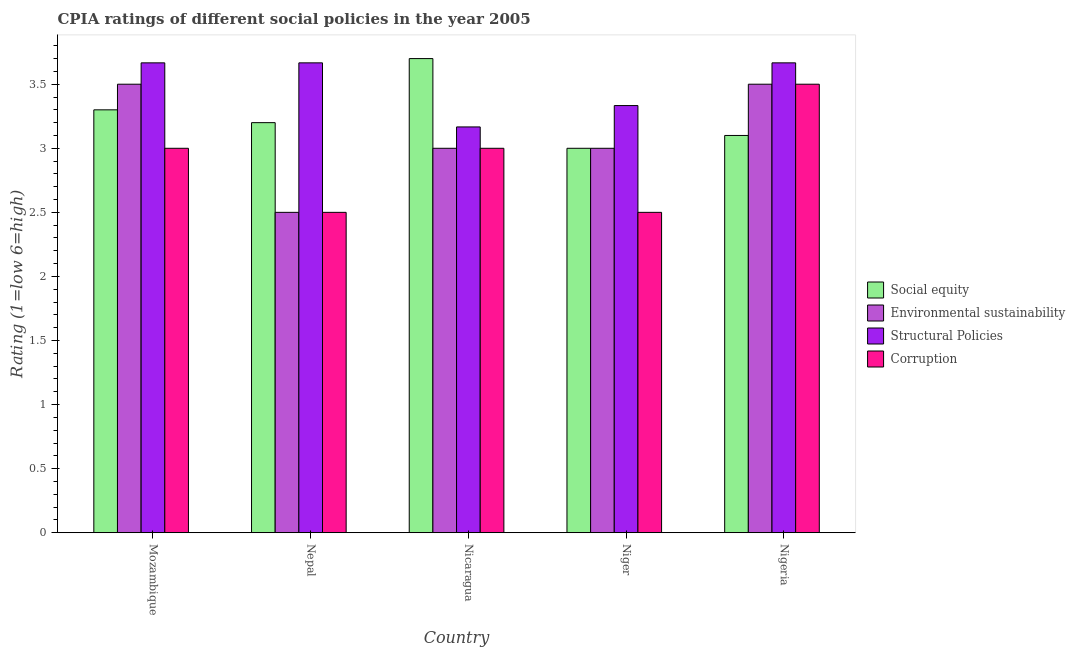How many different coloured bars are there?
Your answer should be very brief. 4. Are the number of bars per tick equal to the number of legend labels?
Your response must be concise. Yes. Are the number of bars on each tick of the X-axis equal?
Your answer should be compact. Yes. How many bars are there on the 3rd tick from the right?
Your answer should be very brief. 4. What is the label of the 5th group of bars from the left?
Ensure brevity in your answer.  Nigeria. What is the cpia rating of structural policies in Nigeria?
Provide a succinct answer. 3.67. Across all countries, what is the maximum cpia rating of social equity?
Keep it short and to the point. 3.7. In which country was the cpia rating of structural policies maximum?
Give a very brief answer. Mozambique. In which country was the cpia rating of environmental sustainability minimum?
Ensure brevity in your answer.  Nepal. What is the difference between the cpia rating of environmental sustainability in Nepal and the cpia rating of social equity in Nigeria?
Make the answer very short. -0.6. What is the difference between the cpia rating of social equity and cpia rating of structural policies in Nepal?
Ensure brevity in your answer.  -0.47. In how many countries, is the cpia rating of corruption greater than 2.5 ?
Give a very brief answer. 3. What is the ratio of the cpia rating of structural policies in Mozambique to that in Nicaragua?
Offer a very short reply. 1.16. Is the cpia rating of structural policies in Nicaragua less than that in Niger?
Give a very brief answer. Yes. Is the difference between the cpia rating of corruption in Nepal and Niger greater than the difference between the cpia rating of social equity in Nepal and Niger?
Offer a terse response. No. What is the difference between the highest and the second highest cpia rating of corruption?
Offer a terse response. 0.5. What does the 2nd bar from the left in Mozambique represents?
Your answer should be compact. Environmental sustainability. What does the 3rd bar from the right in Nicaragua represents?
Keep it short and to the point. Environmental sustainability. Is it the case that in every country, the sum of the cpia rating of social equity and cpia rating of environmental sustainability is greater than the cpia rating of structural policies?
Your response must be concise. Yes. Are all the bars in the graph horizontal?
Your answer should be very brief. No. How many countries are there in the graph?
Give a very brief answer. 5. What is the difference between two consecutive major ticks on the Y-axis?
Your response must be concise. 0.5. Does the graph contain any zero values?
Provide a short and direct response. No. Does the graph contain grids?
Your answer should be very brief. No. How many legend labels are there?
Offer a very short reply. 4. How are the legend labels stacked?
Offer a terse response. Vertical. What is the title of the graph?
Ensure brevity in your answer.  CPIA ratings of different social policies in the year 2005. Does "International Monetary Fund" appear as one of the legend labels in the graph?
Offer a very short reply. No. What is the label or title of the X-axis?
Your response must be concise. Country. What is the Rating (1=low 6=high) in Social equity in Mozambique?
Your answer should be compact. 3.3. What is the Rating (1=low 6=high) of Structural Policies in Mozambique?
Provide a short and direct response. 3.67. What is the Rating (1=low 6=high) of Corruption in Mozambique?
Provide a succinct answer. 3. What is the Rating (1=low 6=high) of Social equity in Nepal?
Offer a very short reply. 3.2. What is the Rating (1=low 6=high) of Structural Policies in Nepal?
Give a very brief answer. 3.67. What is the Rating (1=low 6=high) in Social equity in Nicaragua?
Provide a short and direct response. 3.7. What is the Rating (1=low 6=high) of Structural Policies in Nicaragua?
Offer a very short reply. 3.17. What is the Rating (1=low 6=high) of Environmental sustainability in Niger?
Provide a short and direct response. 3. What is the Rating (1=low 6=high) of Structural Policies in Niger?
Make the answer very short. 3.33. What is the Rating (1=low 6=high) in Corruption in Niger?
Your answer should be compact. 2.5. What is the Rating (1=low 6=high) of Social equity in Nigeria?
Ensure brevity in your answer.  3.1. What is the Rating (1=low 6=high) in Environmental sustainability in Nigeria?
Provide a short and direct response. 3.5. What is the Rating (1=low 6=high) of Structural Policies in Nigeria?
Give a very brief answer. 3.67. Across all countries, what is the maximum Rating (1=low 6=high) of Structural Policies?
Give a very brief answer. 3.67. Across all countries, what is the minimum Rating (1=low 6=high) in Social equity?
Ensure brevity in your answer.  3. Across all countries, what is the minimum Rating (1=low 6=high) in Environmental sustainability?
Give a very brief answer. 2.5. Across all countries, what is the minimum Rating (1=low 6=high) in Structural Policies?
Give a very brief answer. 3.17. Across all countries, what is the minimum Rating (1=low 6=high) of Corruption?
Provide a short and direct response. 2.5. What is the total Rating (1=low 6=high) in Structural Policies in the graph?
Make the answer very short. 17.5. What is the difference between the Rating (1=low 6=high) of Social equity in Mozambique and that in Nepal?
Your answer should be very brief. 0.1. What is the difference between the Rating (1=low 6=high) in Environmental sustainability in Mozambique and that in Nepal?
Offer a very short reply. 1. What is the difference between the Rating (1=low 6=high) of Structural Policies in Mozambique and that in Nepal?
Offer a terse response. 0. What is the difference between the Rating (1=low 6=high) in Environmental sustainability in Mozambique and that in Nicaragua?
Ensure brevity in your answer.  0.5. What is the difference between the Rating (1=low 6=high) in Structural Policies in Mozambique and that in Nicaragua?
Make the answer very short. 0.5. What is the difference between the Rating (1=low 6=high) in Social equity in Mozambique and that in Niger?
Your response must be concise. 0.3. What is the difference between the Rating (1=low 6=high) of Corruption in Mozambique and that in Niger?
Your response must be concise. 0.5. What is the difference between the Rating (1=low 6=high) of Environmental sustainability in Mozambique and that in Nigeria?
Keep it short and to the point. 0. What is the difference between the Rating (1=low 6=high) in Structural Policies in Mozambique and that in Nigeria?
Provide a succinct answer. 0. What is the difference between the Rating (1=low 6=high) of Environmental sustainability in Nepal and that in Nicaragua?
Provide a short and direct response. -0.5. What is the difference between the Rating (1=low 6=high) of Corruption in Nepal and that in Nicaragua?
Provide a short and direct response. -0.5. What is the difference between the Rating (1=low 6=high) in Social equity in Nepal and that in Niger?
Provide a succinct answer. 0.2. What is the difference between the Rating (1=low 6=high) of Corruption in Nepal and that in Niger?
Your answer should be very brief. 0. What is the difference between the Rating (1=low 6=high) in Social equity in Nepal and that in Nigeria?
Provide a short and direct response. 0.1. What is the difference between the Rating (1=low 6=high) of Corruption in Nepal and that in Nigeria?
Ensure brevity in your answer.  -1. What is the difference between the Rating (1=low 6=high) of Social equity in Nicaragua and that in Niger?
Give a very brief answer. 0.7. What is the difference between the Rating (1=low 6=high) of Structural Policies in Nicaragua and that in Niger?
Ensure brevity in your answer.  -0.17. What is the difference between the Rating (1=low 6=high) of Social equity in Nicaragua and that in Nigeria?
Keep it short and to the point. 0.6. What is the difference between the Rating (1=low 6=high) of Environmental sustainability in Nicaragua and that in Nigeria?
Your answer should be compact. -0.5. What is the difference between the Rating (1=low 6=high) of Structural Policies in Nicaragua and that in Nigeria?
Provide a short and direct response. -0.5. What is the difference between the Rating (1=low 6=high) in Corruption in Nicaragua and that in Nigeria?
Ensure brevity in your answer.  -0.5. What is the difference between the Rating (1=low 6=high) in Structural Policies in Niger and that in Nigeria?
Provide a short and direct response. -0.33. What is the difference between the Rating (1=low 6=high) of Corruption in Niger and that in Nigeria?
Keep it short and to the point. -1. What is the difference between the Rating (1=low 6=high) of Social equity in Mozambique and the Rating (1=low 6=high) of Environmental sustainability in Nepal?
Your response must be concise. 0.8. What is the difference between the Rating (1=low 6=high) of Social equity in Mozambique and the Rating (1=low 6=high) of Structural Policies in Nepal?
Your answer should be very brief. -0.37. What is the difference between the Rating (1=low 6=high) in Structural Policies in Mozambique and the Rating (1=low 6=high) in Corruption in Nepal?
Offer a very short reply. 1.17. What is the difference between the Rating (1=low 6=high) in Social equity in Mozambique and the Rating (1=low 6=high) in Environmental sustainability in Nicaragua?
Keep it short and to the point. 0.3. What is the difference between the Rating (1=low 6=high) of Social equity in Mozambique and the Rating (1=low 6=high) of Structural Policies in Nicaragua?
Provide a succinct answer. 0.13. What is the difference between the Rating (1=low 6=high) in Social equity in Mozambique and the Rating (1=low 6=high) in Corruption in Nicaragua?
Provide a succinct answer. 0.3. What is the difference between the Rating (1=low 6=high) of Environmental sustainability in Mozambique and the Rating (1=low 6=high) of Structural Policies in Nicaragua?
Provide a succinct answer. 0.33. What is the difference between the Rating (1=low 6=high) of Environmental sustainability in Mozambique and the Rating (1=low 6=high) of Corruption in Nicaragua?
Your response must be concise. 0.5. What is the difference between the Rating (1=low 6=high) in Structural Policies in Mozambique and the Rating (1=low 6=high) in Corruption in Nicaragua?
Offer a terse response. 0.67. What is the difference between the Rating (1=low 6=high) in Social equity in Mozambique and the Rating (1=low 6=high) in Environmental sustainability in Niger?
Give a very brief answer. 0.3. What is the difference between the Rating (1=low 6=high) in Social equity in Mozambique and the Rating (1=low 6=high) in Structural Policies in Niger?
Your answer should be very brief. -0.03. What is the difference between the Rating (1=low 6=high) in Social equity in Mozambique and the Rating (1=low 6=high) in Corruption in Niger?
Offer a terse response. 0.8. What is the difference between the Rating (1=low 6=high) of Environmental sustainability in Mozambique and the Rating (1=low 6=high) of Structural Policies in Niger?
Offer a very short reply. 0.17. What is the difference between the Rating (1=low 6=high) in Environmental sustainability in Mozambique and the Rating (1=low 6=high) in Corruption in Niger?
Give a very brief answer. 1. What is the difference between the Rating (1=low 6=high) of Structural Policies in Mozambique and the Rating (1=low 6=high) of Corruption in Niger?
Your answer should be compact. 1.17. What is the difference between the Rating (1=low 6=high) in Social equity in Mozambique and the Rating (1=low 6=high) in Environmental sustainability in Nigeria?
Give a very brief answer. -0.2. What is the difference between the Rating (1=low 6=high) of Social equity in Mozambique and the Rating (1=low 6=high) of Structural Policies in Nigeria?
Your answer should be very brief. -0.37. What is the difference between the Rating (1=low 6=high) of Environmental sustainability in Mozambique and the Rating (1=low 6=high) of Structural Policies in Nigeria?
Your answer should be very brief. -0.17. What is the difference between the Rating (1=low 6=high) of Environmental sustainability in Mozambique and the Rating (1=low 6=high) of Corruption in Nigeria?
Offer a very short reply. 0. What is the difference between the Rating (1=low 6=high) of Social equity in Nepal and the Rating (1=low 6=high) of Structural Policies in Nicaragua?
Make the answer very short. 0.03. What is the difference between the Rating (1=low 6=high) in Social equity in Nepal and the Rating (1=low 6=high) in Corruption in Nicaragua?
Ensure brevity in your answer.  0.2. What is the difference between the Rating (1=low 6=high) in Structural Policies in Nepal and the Rating (1=low 6=high) in Corruption in Nicaragua?
Offer a very short reply. 0.67. What is the difference between the Rating (1=low 6=high) in Social equity in Nepal and the Rating (1=low 6=high) in Environmental sustainability in Niger?
Provide a succinct answer. 0.2. What is the difference between the Rating (1=low 6=high) of Social equity in Nepal and the Rating (1=low 6=high) of Structural Policies in Niger?
Give a very brief answer. -0.13. What is the difference between the Rating (1=low 6=high) in Environmental sustainability in Nepal and the Rating (1=low 6=high) in Structural Policies in Niger?
Ensure brevity in your answer.  -0.83. What is the difference between the Rating (1=low 6=high) of Social equity in Nepal and the Rating (1=low 6=high) of Structural Policies in Nigeria?
Your response must be concise. -0.47. What is the difference between the Rating (1=low 6=high) in Social equity in Nepal and the Rating (1=low 6=high) in Corruption in Nigeria?
Keep it short and to the point. -0.3. What is the difference between the Rating (1=low 6=high) of Environmental sustainability in Nepal and the Rating (1=low 6=high) of Structural Policies in Nigeria?
Give a very brief answer. -1.17. What is the difference between the Rating (1=low 6=high) in Environmental sustainability in Nepal and the Rating (1=low 6=high) in Corruption in Nigeria?
Your answer should be compact. -1. What is the difference between the Rating (1=low 6=high) in Social equity in Nicaragua and the Rating (1=low 6=high) in Structural Policies in Niger?
Give a very brief answer. 0.37. What is the difference between the Rating (1=low 6=high) in Social equity in Nicaragua and the Rating (1=low 6=high) in Corruption in Niger?
Offer a very short reply. 1.2. What is the difference between the Rating (1=low 6=high) of Environmental sustainability in Nicaragua and the Rating (1=low 6=high) of Corruption in Niger?
Provide a short and direct response. 0.5. What is the difference between the Rating (1=low 6=high) in Structural Policies in Nicaragua and the Rating (1=low 6=high) in Corruption in Niger?
Give a very brief answer. 0.67. What is the difference between the Rating (1=low 6=high) in Social equity in Nicaragua and the Rating (1=low 6=high) in Structural Policies in Nigeria?
Offer a terse response. 0.03. What is the difference between the Rating (1=low 6=high) in Social equity in Nicaragua and the Rating (1=low 6=high) in Corruption in Nigeria?
Offer a terse response. 0.2. What is the difference between the Rating (1=low 6=high) in Environmental sustainability in Nicaragua and the Rating (1=low 6=high) in Structural Policies in Nigeria?
Offer a terse response. -0.67. What is the difference between the Rating (1=low 6=high) of Structural Policies in Nicaragua and the Rating (1=low 6=high) of Corruption in Nigeria?
Your answer should be very brief. -0.33. What is the difference between the Rating (1=low 6=high) of Social equity in Niger and the Rating (1=low 6=high) of Environmental sustainability in Nigeria?
Make the answer very short. -0.5. What is the difference between the Rating (1=low 6=high) of Structural Policies in Niger and the Rating (1=low 6=high) of Corruption in Nigeria?
Make the answer very short. -0.17. What is the average Rating (1=low 6=high) of Social equity per country?
Provide a short and direct response. 3.26. What is the average Rating (1=low 6=high) of Environmental sustainability per country?
Your response must be concise. 3.1. What is the average Rating (1=low 6=high) of Corruption per country?
Offer a terse response. 2.9. What is the difference between the Rating (1=low 6=high) in Social equity and Rating (1=low 6=high) in Environmental sustainability in Mozambique?
Keep it short and to the point. -0.2. What is the difference between the Rating (1=low 6=high) of Social equity and Rating (1=low 6=high) of Structural Policies in Mozambique?
Make the answer very short. -0.37. What is the difference between the Rating (1=low 6=high) of Social equity and Rating (1=low 6=high) of Structural Policies in Nepal?
Provide a short and direct response. -0.47. What is the difference between the Rating (1=low 6=high) in Environmental sustainability and Rating (1=low 6=high) in Structural Policies in Nepal?
Provide a succinct answer. -1.17. What is the difference between the Rating (1=low 6=high) in Structural Policies and Rating (1=low 6=high) in Corruption in Nepal?
Your answer should be very brief. 1.17. What is the difference between the Rating (1=low 6=high) in Social equity and Rating (1=low 6=high) in Structural Policies in Nicaragua?
Your response must be concise. 0.53. What is the difference between the Rating (1=low 6=high) of Social equity and Rating (1=low 6=high) of Corruption in Nicaragua?
Offer a very short reply. 0.7. What is the difference between the Rating (1=low 6=high) in Environmental sustainability and Rating (1=low 6=high) in Structural Policies in Nicaragua?
Keep it short and to the point. -0.17. What is the difference between the Rating (1=low 6=high) in Environmental sustainability and Rating (1=low 6=high) in Corruption in Nicaragua?
Offer a very short reply. 0. What is the difference between the Rating (1=low 6=high) in Structural Policies and Rating (1=low 6=high) in Corruption in Nicaragua?
Ensure brevity in your answer.  0.17. What is the difference between the Rating (1=low 6=high) of Social equity and Rating (1=low 6=high) of Structural Policies in Niger?
Your answer should be compact. -0.33. What is the difference between the Rating (1=low 6=high) in Social equity and Rating (1=low 6=high) in Corruption in Niger?
Ensure brevity in your answer.  0.5. What is the difference between the Rating (1=low 6=high) in Environmental sustainability and Rating (1=low 6=high) in Structural Policies in Niger?
Offer a terse response. -0.33. What is the difference between the Rating (1=low 6=high) in Social equity and Rating (1=low 6=high) in Structural Policies in Nigeria?
Ensure brevity in your answer.  -0.57. What is the difference between the Rating (1=low 6=high) in Environmental sustainability and Rating (1=low 6=high) in Structural Policies in Nigeria?
Offer a very short reply. -0.17. What is the difference between the Rating (1=low 6=high) in Structural Policies and Rating (1=low 6=high) in Corruption in Nigeria?
Offer a very short reply. 0.17. What is the ratio of the Rating (1=low 6=high) in Social equity in Mozambique to that in Nepal?
Ensure brevity in your answer.  1.03. What is the ratio of the Rating (1=low 6=high) of Environmental sustainability in Mozambique to that in Nepal?
Offer a very short reply. 1.4. What is the ratio of the Rating (1=low 6=high) of Structural Policies in Mozambique to that in Nepal?
Your answer should be very brief. 1. What is the ratio of the Rating (1=low 6=high) of Corruption in Mozambique to that in Nepal?
Your answer should be very brief. 1.2. What is the ratio of the Rating (1=low 6=high) in Social equity in Mozambique to that in Nicaragua?
Make the answer very short. 0.89. What is the ratio of the Rating (1=low 6=high) of Structural Policies in Mozambique to that in Nicaragua?
Provide a succinct answer. 1.16. What is the ratio of the Rating (1=low 6=high) in Corruption in Mozambique to that in Nicaragua?
Keep it short and to the point. 1. What is the ratio of the Rating (1=low 6=high) of Social equity in Mozambique to that in Niger?
Offer a terse response. 1.1. What is the ratio of the Rating (1=low 6=high) in Structural Policies in Mozambique to that in Niger?
Your answer should be compact. 1.1. What is the ratio of the Rating (1=low 6=high) of Social equity in Mozambique to that in Nigeria?
Offer a very short reply. 1.06. What is the ratio of the Rating (1=low 6=high) in Social equity in Nepal to that in Nicaragua?
Make the answer very short. 0.86. What is the ratio of the Rating (1=low 6=high) in Structural Policies in Nepal to that in Nicaragua?
Keep it short and to the point. 1.16. What is the ratio of the Rating (1=low 6=high) in Social equity in Nepal to that in Niger?
Your answer should be very brief. 1.07. What is the ratio of the Rating (1=low 6=high) of Environmental sustainability in Nepal to that in Niger?
Provide a succinct answer. 0.83. What is the ratio of the Rating (1=low 6=high) of Structural Policies in Nepal to that in Niger?
Provide a succinct answer. 1.1. What is the ratio of the Rating (1=low 6=high) of Social equity in Nepal to that in Nigeria?
Give a very brief answer. 1.03. What is the ratio of the Rating (1=low 6=high) of Environmental sustainability in Nepal to that in Nigeria?
Make the answer very short. 0.71. What is the ratio of the Rating (1=low 6=high) of Structural Policies in Nepal to that in Nigeria?
Give a very brief answer. 1. What is the ratio of the Rating (1=low 6=high) in Social equity in Nicaragua to that in Niger?
Keep it short and to the point. 1.23. What is the ratio of the Rating (1=low 6=high) of Structural Policies in Nicaragua to that in Niger?
Make the answer very short. 0.95. What is the ratio of the Rating (1=low 6=high) in Social equity in Nicaragua to that in Nigeria?
Offer a very short reply. 1.19. What is the ratio of the Rating (1=low 6=high) in Environmental sustainability in Nicaragua to that in Nigeria?
Provide a succinct answer. 0.86. What is the ratio of the Rating (1=low 6=high) of Structural Policies in Nicaragua to that in Nigeria?
Your answer should be compact. 0.86. What is the ratio of the Rating (1=low 6=high) in Social equity in Niger to that in Nigeria?
Your answer should be compact. 0.97. What is the ratio of the Rating (1=low 6=high) in Environmental sustainability in Niger to that in Nigeria?
Your response must be concise. 0.86. What is the difference between the highest and the second highest Rating (1=low 6=high) in Social equity?
Keep it short and to the point. 0.4. What is the difference between the highest and the second highest Rating (1=low 6=high) in Structural Policies?
Offer a very short reply. 0. What is the difference between the highest and the lowest Rating (1=low 6=high) of Structural Policies?
Keep it short and to the point. 0.5. 